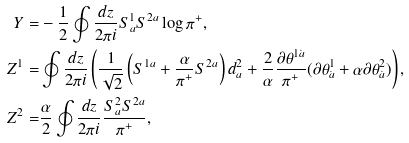Convert formula to latex. <formula><loc_0><loc_0><loc_500><loc_500>Y = & - \frac { 1 } { 2 } \oint \frac { d z } { 2 \pi i } S ^ { 1 } _ { a } S ^ { 2 a } \log \pi ^ { + } , \\ Z ^ { 1 } = & \oint \frac { d z } { 2 \pi i } \left ( \frac { 1 } { \sqrt { 2 } } \left ( S ^ { 1 a } + \frac { \alpha } { \pi ^ { + } } S ^ { 2 a } \right ) d ^ { 2 } _ { a } + \frac { 2 } { \alpha } \frac { \partial \theta ^ { 1 \dot { a } } } { \pi ^ { + } } ( \partial \theta ^ { 1 } _ { \dot { a } } + \alpha \partial \theta ^ { 2 } _ { \dot { a } } ) \right ) , \\ Z ^ { 2 } = & \frac { \alpha } { 2 } \oint \frac { d z } { 2 \pi i } \frac { S ^ { 2 } _ { a } S ^ { 2 a } } { \pi ^ { + } } ,</formula> 